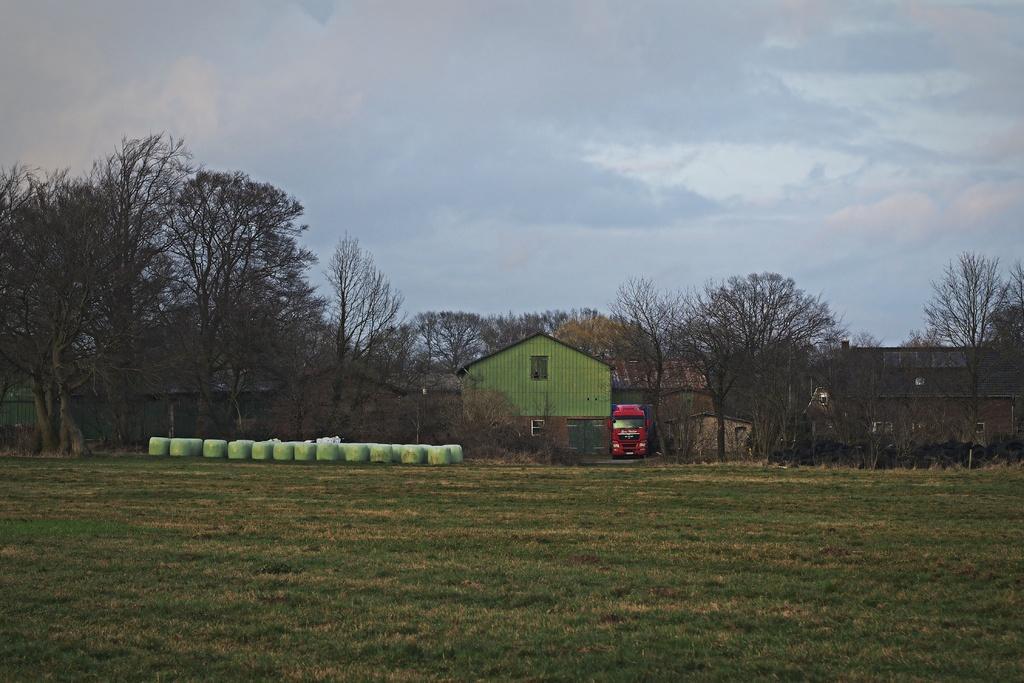In one or two sentences, can you explain what this image depicts? In this picture we can see the grass, vehicle, sheds, trees, wall, some objects and in the background we can see the sky with clouds. 